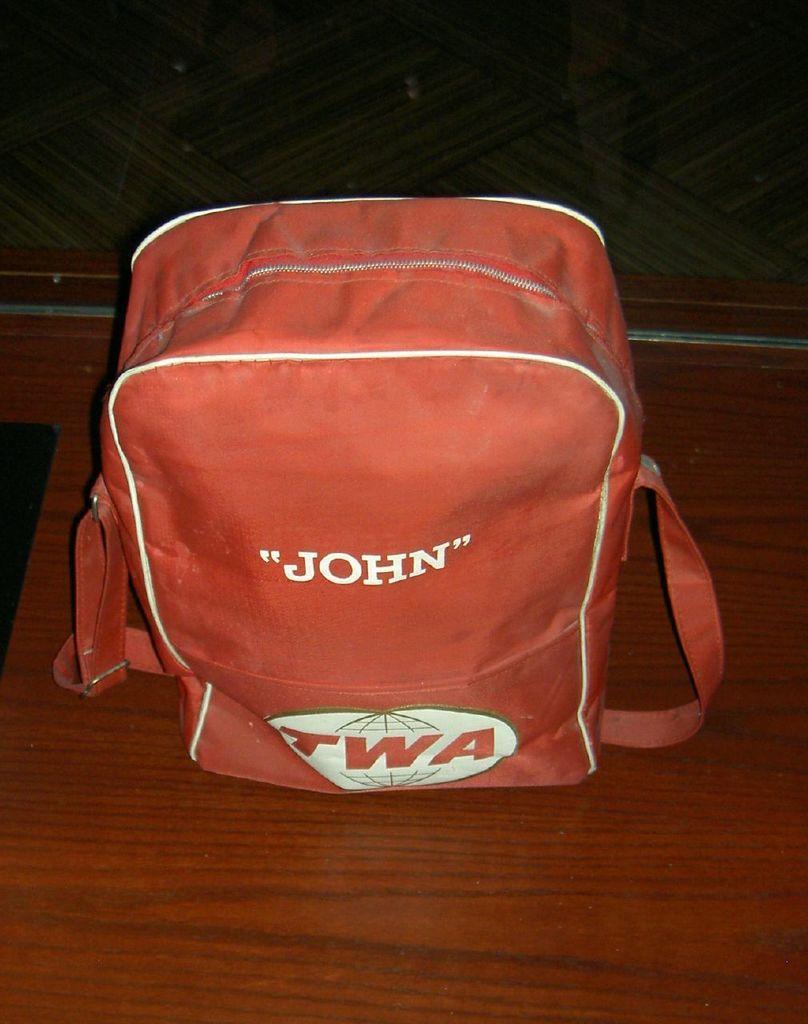How would you summarize this image in a sentence or two? In this picture we can see a bag on a platform and we can see a wall in the background. 